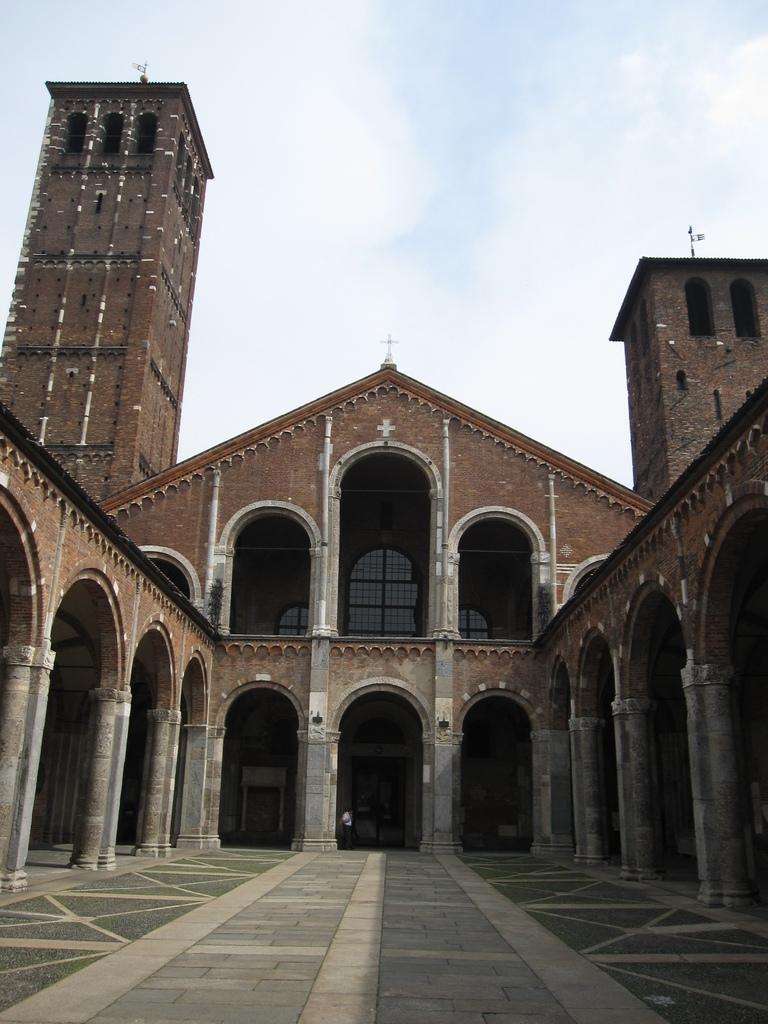How would you summarize this image in a sentence or two? In this picture we can see a building and a person and in the background we can see the sky. 